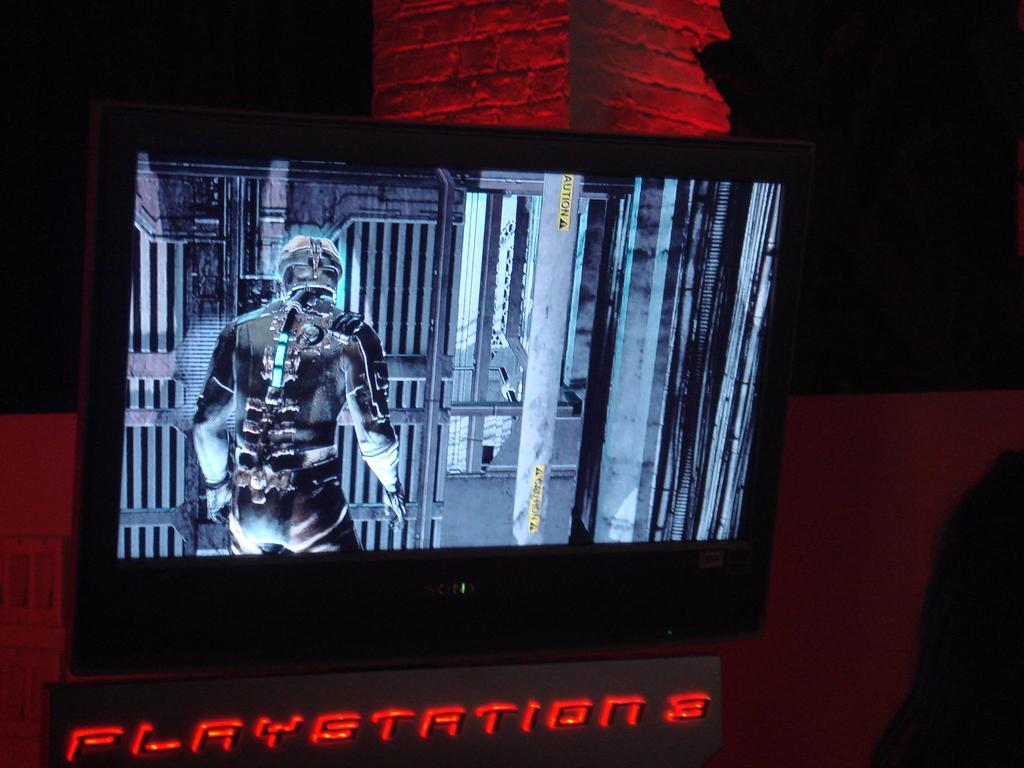<image>
Present a compact description of the photo's key features. A TV with a game being played says PlayStation 3 on the stand. 